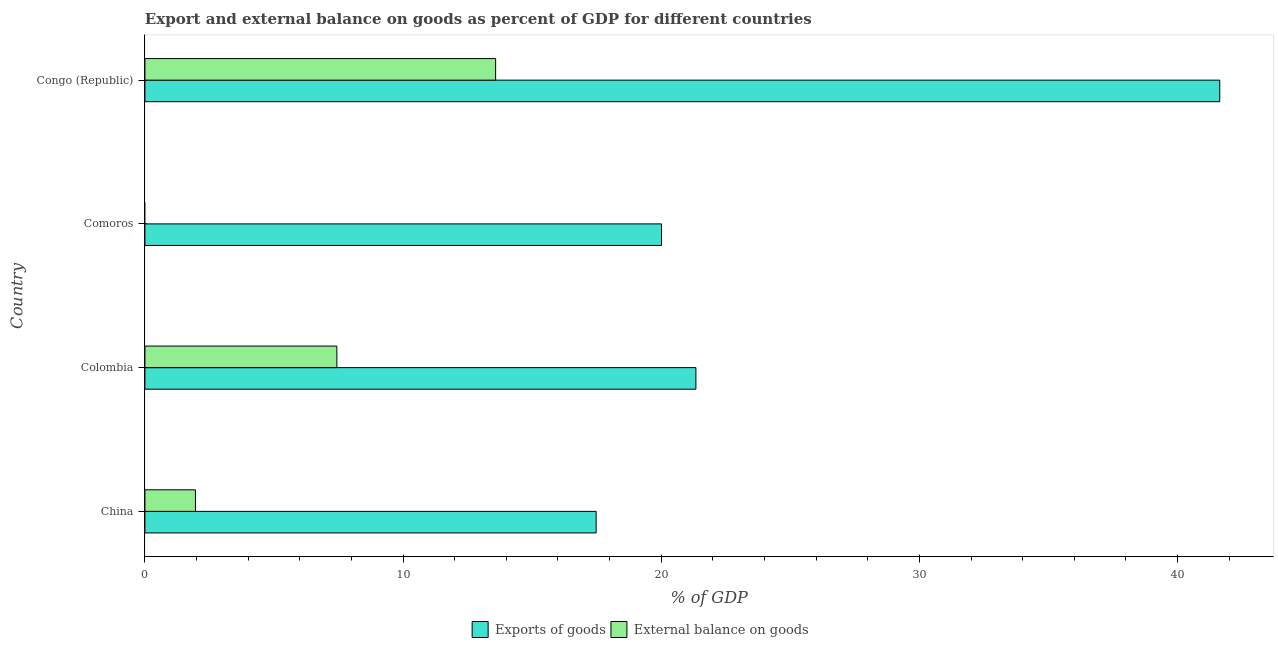How many bars are there on the 1st tick from the top?
Give a very brief answer. 2. How many bars are there on the 4th tick from the bottom?
Your response must be concise. 2. What is the export of goods as percentage of gdp in Comoros?
Give a very brief answer. 20.01. Across all countries, what is the maximum export of goods as percentage of gdp?
Offer a very short reply. 41.63. In which country was the export of goods as percentage of gdp maximum?
Give a very brief answer. Congo (Republic). What is the total export of goods as percentage of gdp in the graph?
Offer a terse response. 100.47. What is the difference between the external balance on goods as percentage of gdp in China and that in Colombia?
Ensure brevity in your answer.  -5.48. What is the difference between the export of goods as percentage of gdp in Comoros and the external balance on goods as percentage of gdp in Congo (Republic)?
Your response must be concise. 6.43. What is the average export of goods as percentage of gdp per country?
Ensure brevity in your answer.  25.12. What is the difference between the export of goods as percentage of gdp and external balance on goods as percentage of gdp in China?
Provide a short and direct response. 15.52. What is the ratio of the export of goods as percentage of gdp in China to that in Congo (Republic)?
Make the answer very short. 0.42. Is the external balance on goods as percentage of gdp in Colombia less than that in Congo (Republic)?
Give a very brief answer. Yes. What is the difference between the highest and the second highest export of goods as percentage of gdp?
Provide a short and direct response. 20.29. What is the difference between the highest and the lowest external balance on goods as percentage of gdp?
Keep it short and to the point. 13.58. How many countries are there in the graph?
Make the answer very short. 4. Are the values on the major ticks of X-axis written in scientific E-notation?
Make the answer very short. No. Does the graph contain any zero values?
Provide a short and direct response. Yes. How many legend labels are there?
Your answer should be compact. 2. What is the title of the graph?
Offer a very short reply. Export and external balance on goods as percent of GDP for different countries. Does "Investment in Transport" appear as one of the legend labels in the graph?
Keep it short and to the point. No. What is the label or title of the X-axis?
Your answer should be compact. % of GDP. What is the % of GDP of Exports of goods in China?
Offer a terse response. 17.48. What is the % of GDP in External balance on goods in China?
Give a very brief answer. 1.96. What is the % of GDP of Exports of goods in Colombia?
Make the answer very short. 21.34. What is the % of GDP of External balance on goods in Colombia?
Make the answer very short. 7.43. What is the % of GDP of Exports of goods in Comoros?
Keep it short and to the point. 20.01. What is the % of GDP of Exports of goods in Congo (Republic)?
Provide a succinct answer. 41.63. What is the % of GDP in External balance on goods in Congo (Republic)?
Your answer should be very brief. 13.58. Across all countries, what is the maximum % of GDP of Exports of goods?
Ensure brevity in your answer.  41.63. Across all countries, what is the maximum % of GDP in External balance on goods?
Make the answer very short. 13.58. Across all countries, what is the minimum % of GDP of Exports of goods?
Your response must be concise. 17.48. What is the total % of GDP of Exports of goods in the graph?
Your answer should be compact. 100.47. What is the total % of GDP of External balance on goods in the graph?
Give a very brief answer. 22.98. What is the difference between the % of GDP of Exports of goods in China and that in Colombia?
Make the answer very short. -3.86. What is the difference between the % of GDP of External balance on goods in China and that in Colombia?
Your answer should be compact. -5.48. What is the difference between the % of GDP in Exports of goods in China and that in Comoros?
Offer a terse response. -2.53. What is the difference between the % of GDP in Exports of goods in China and that in Congo (Republic)?
Keep it short and to the point. -24.16. What is the difference between the % of GDP of External balance on goods in China and that in Congo (Republic)?
Your response must be concise. -11.63. What is the difference between the % of GDP in Exports of goods in Colombia and that in Comoros?
Provide a short and direct response. 1.33. What is the difference between the % of GDP in Exports of goods in Colombia and that in Congo (Republic)?
Your response must be concise. -20.29. What is the difference between the % of GDP of External balance on goods in Colombia and that in Congo (Republic)?
Provide a short and direct response. -6.15. What is the difference between the % of GDP of Exports of goods in Comoros and that in Congo (Republic)?
Your answer should be very brief. -21.62. What is the difference between the % of GDP of Exports of goods in China and the % of GDP of External balance on goods in Colombia?
Provide a succinct answer. 10.04. What is the difference between the % of GDP of Exports of goods in China and the % of GDP of External balance on goods in Congo (Republic)?
Provide a short and direct response. 3.89. What is the difference between the % of GDP in Exports of goods in Colombia and the % of GDP in External balance on goods in Congo (Republic)?
Your answer should be compact. 7.76. What is the difference between the % of GDP of Exports of goods in Comoros and the % of GDP of External balance on goods in Congo (Republic)?
Your response must be concise. 6.43. What is the average % of GDP of Exports of goods per country?
Ensure brevity in your answer.  25.12. What is the average % of GDP in External balance on goods per country?
Keep it short and to the point. 5.74. What is the difference between the % of GDP of Exports of goods and % of GDP of External balance on goods in China?
Offer a terse response. 15.52. What is the difference between the % of GDP in Exports of goods and % of GDP in External balance on goods in Colombia?
Give a very brief answer. 13.91. What is the difference between the % of GDP of Exports of goods and % of GDP of External balance on goods in Congo (Republic)?
Your answer should be compact. 28.05. What is the ratio of the % of GDP of Exports of goods in China to that in Colombia?
Keep it short and to the point. 0.82. What is the ratio of the % of GDP of External balance on goods in China to that in Colombia?
Offer a very short reply. 0.26. What is the ratio of the % of GDP in Exports of goods in China to that in Comoros?
Your answer should be very brief. 0.87. What is the ratio of the % of GDP of Exports of goods in China to that in Congo (Republic)?
Offer a very short reply. 0.42. What is the ratio of the % of GDP of External balance on goods in China to that in Congo (Republic)?
Provide a short and direct response. 0.14. What is the ratio of the % of GDP in Exports of goods in Colombia to that in Comoros?
Ensure brevity in your answer.  1.07. What is the ratio of the % of GDP of Exports of goods in Colombia to that in Congo (Republic)?
Make the answer very short. 0.51. What is the ratio of the % of GDP of External balance on goods in Colombia to that in Congo (Republic)?
Give a very brief answer. 0.55. What is the ratio of the % of GDP in Exports of goods in Comoros to that in Congo (Republic)?
Your answer should be compact. 0.48. What is the difference between the highest and the second highest % of GDP in Exports of goods?
Your answer should be compact. 20.29. What is the difference between the highest and the second highest % of GDP of External balance on goods?
Give a very brief answer. 6.15. What is the difference between the highest and the lowest % of GDP of Exports of goods?
Your response must be concise. 24.16. What is the difference between the highest and the lowest % of GDP of External balance on goods?
Keep it short and to the point. 13.58. 